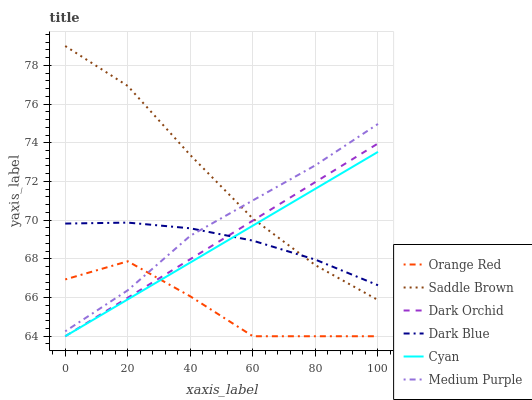Does Orange Red have the minimum area under the curve?
Answer yes or no. Yes. Does Saddle Brown have the maximum area under the curve?
Answer yes or no. Yes. Does Medium Purple have the minimum area under the curve?
Answer yes or no. No. Does Medium Purple have the maximum area under the curve?
Answer yes or no. No. Is Dark Orchid the smoothest?
Answer yes or no. Yes. Is Orange Red the roughest?
Answer yes or no. Yes. Is Saddle Brown the smoothest?
Answer yes or no. No. Is Saddle Brown the roughest?
Answer yes or no. No. Does Dark Orchid have the lowest value?
Answer yes or no. Yes. Does Saddle Brown have the lowest value?
Answer yes or no. No. Does Saddle Brown have the highest value?
Answer yes or no. Yes. Does Medium Purple have the highest value?
Answer yes or no. No. Is Orange Red less than Dark Blue?
Answer yes or no. Yes. Is Medium Purple greater than Dark Orchid?
Answer yes or no. Yes. Does Dark Orchid intersect Dark Blue?
Answer yes or no. Yes. Is Dark Orchid less than Dark Blue?
Answer yes or no. No. Is Dark Orchid greater than Dark Blue?
Answer yes or no. No. Does Orange Red intersect Dark Blue?
Answer yes or no. No. 